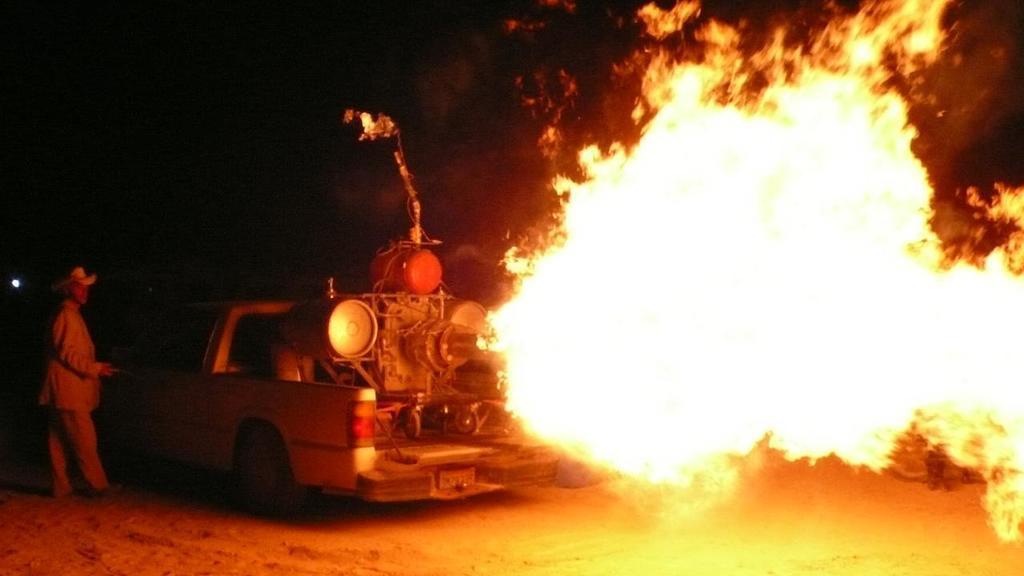Please provide a concise description of this image. There is a person in a suit standing on the ground near a vehicle. There is an object on the truck of this vehicle is emitting fire. And the background is dark in color. 